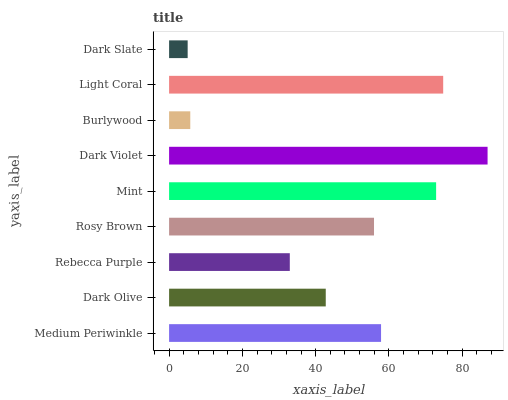Is Dark Slate the minimum?
Answer yes or no. Yes. Is Dark Violet the maximum?
Answer yes or no. Yes. Is Dark Olive the minimum?
Answer yes or no. No. Is Dark Olive the maximum?
Answer yes or no. No. Is Medium Periwinkle greater than Dark Olive?
Answer yes or no. Yes. Is Dark Olive less than Medium Periwinkle?
Answer yes or no. Yes. Is Dark Olive greater than Medium Periwinkle?
Answer yes or no. No. Is Medium Periwinkle less than Dark Olive?
Answer yes or no. No. Is Rosy Brown the high median?
Answer yes or no. Yes. Is Rosy Brown the low median?
Answer yes or no. Yes. Is Dark Olive the high median?
Answer yes or no. No. Is Mint the low median?
Answer yes or no. No. 